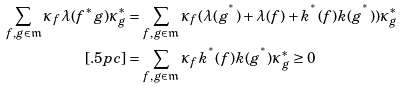Convert formula to latex. <formula><loc_0><loc_0><loc_500><loc_500>\sum _ { f , g \in \mathfrak { m } } \kappa _ { f } \lambda ( f ^ { * } g ) \kappa _ { g } ^ { \ast } & = \sum _ { f , g \in \mathfrak { m } } \kappa _ { f } ( \lambda ( g ^ { ^ { * } } ) + \lambda ( f ) + k ^ { ^ { * } } ( f ) k ( g ^ { ^ { * } } ) ) \kappa _ { g } ^ { \ast } \\ [ . 5 p c ] & = \sum _ { f , g \in \mathfrak { m } } \kappa _ { f } k ^ { ^ { * } } ( f ) k ( g ^ { ^ { * } } ) \kappa _ { g } ^ { \ast } \geq 0</formula> 